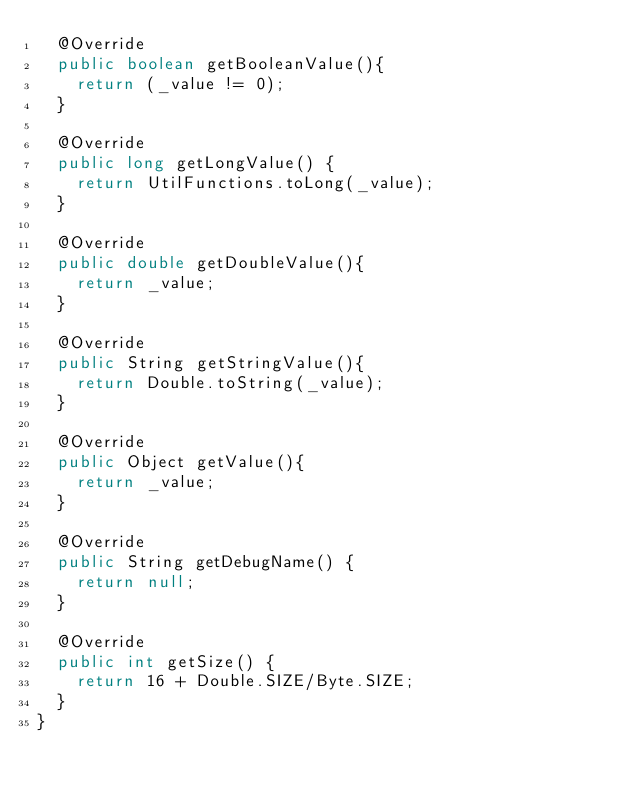<code> <loc_0><loc_0><loc_500><loc_500><_Java_>	@Override
	public boolean getBooleanValue(){
		return (_value != 0);
	}

	@Override
	public long getLongValue() {
		return UtilFunctions.toLong(_value);
	}
	
	@Override
	public double getDoubleValue(){
		return _value;
	}
	
	@Override
	public String getStringValue(){
		return Double.toString(_value);
	}
	
	@Override
	public Object getValue(){
		return _value;
	}

	@Override
	public String getDebugName() {
		return null;
	}
	
	@Override
	public int getSize() {
		return 16 + Double.SIZE/Byte.SIZE;
	}
}
</code> 